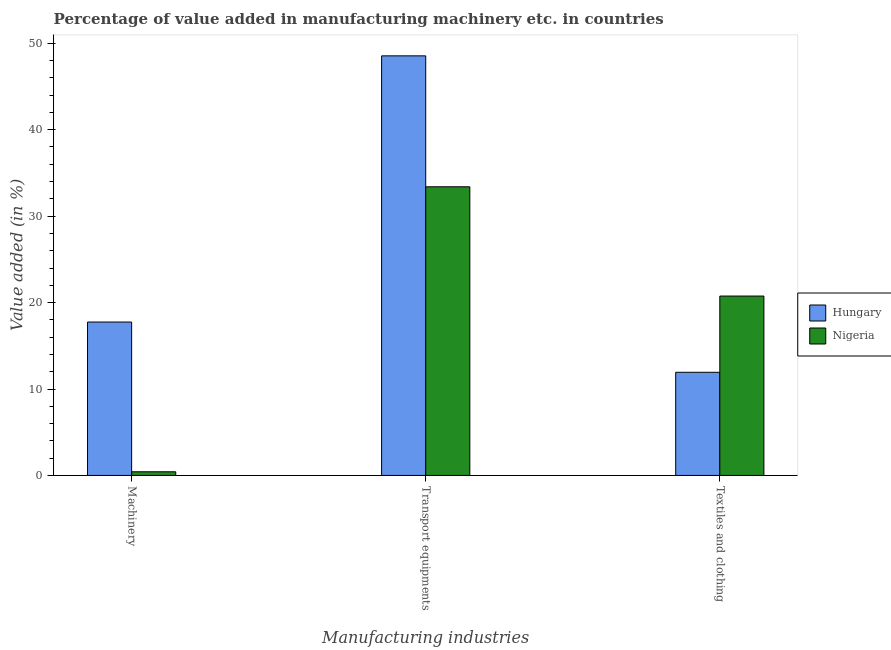How many groups of bars are there?
Provide a succinct answer. 3. How many bars are there on the 3rd tick from the left?
Ensure brevity in your answer.  2. How many bars are there on the 1st tick from the right?
Keep it short and to the point. 2. What is the label of the 2nd group of bars from the left?
Keep it short and to the point. Transport equipments. What is the value added in manufacturing transport equipments in Hungary?
Offer a terse response. 48.54. Across all countries, what is the maximum value added in manufacturing transport equipments?
Ensure brevity in your answer.  48.54. Across all countries, what is the minimum value added in manufacturing transport equipments?
Make the answer very short. 33.4. In which country was the value added in manufacturing transport equipments maximum?
Keep it short and to the point. Hungary. In which country was the value added in manufacturing textile and clothing minimum?
Your answer should be compact. Hungary. What is the total value added in manufacturing textile and clothing in the graph?
Provide a short and direct response. 32.69. What is the difference between the value added in manufacturing textile and clothing in Nigeria and that in Hungary?
Provide a short and direct response. 8.82. What is the difference between the value added in manufacturing textile and clothing in Nigeria and the value added in manufacturing machinery in Hungary?
Keep it short and to the point. 3.01. What is the average value added in manufacturing textile and clothing per country?
Provide a succinct answer. 16.34. What is the difference between the value added in manufacturing transport equipments and value added in manufacturing machinery in Hungary?
Your answer should be very brief. 30.8. What is the ratio of the value added in manufacturing machinery in Hungary to that in Nigeria?
Give a very brief answer. 41.93. Is the difference between the value added in manufacturing transport equipments in Hungary and Nigeria greater than the difference between the value added in manufacturing textile and clothing in Hungary and Nigeria?
Offer a terse response. Yes. What is the difference between the highest and the second highest value added in manufacturing textile and clothing?
Offer a very short reply. 8.82. What is the difference between the highest and the lowest value added in manufacturing machinery?
Your response must be concise. 17.33. In how many countries, is the value added in manufacturing textile and clothing greater than the average value added in manufacturing textile and clothing taken over all countries?
Provide a succinct answer. 1. What does the 1st bar from the left in Machinery represents?
Offer a terse response. Hungary. What does the 2nd bar from the right in Textiles and clothing represents?
Keep it short and to the point. Hungary. Are all the bars in the graph horizontal?
Offer a very short reply. No. Are the values on the major ticks of Y-axis written in scientific E-notation?
Offer a terse response. No. Where does the legend appear in the graph?
Provide a short and direct response. Center right. How are the legend labels stacked?
Offer a very short reply. Vertical. What is the title of the graph?
Make the answer very short. Percentage of value added in manufacturing machinery etc. in countries. What is the label or title of the X-axis?
Provide a short and direct response. Manufacturing industries. What is the label or title of the Y-axis?
Make the answer very short. Value added (in %). What is the Value added (in %) in Hungary in Machinery?
Provide a short and direct response. 17.75. What is the Value added (in %) of Nigeria in Machinery?
Your answer should be compact. 0.42. What is the Value added (in %) in Hungary in Transport equipments?
Provide a short and direct response. 48.54. What is the Value added (in %) of Nigeria in Transport equipments?
Ensure brevity in your answer.  33.4. What is the Value added (in %) of Hungary in Textiles and clothing?
Your answer should be very brief. 11.94. What is the Value added (in %) of Nigeria in Textiles and clothing?
Provide a short and direct response. 20.75. Across all Manufacturing industries, what is the maximum Value added (in %) of Hungary?
Keep it short and to the point. 48.54. Across all Manufacturing industries, what is the maximum Value added (in %) of Nigeria?
Offer a very short reply. 33.4. Across all Manufacturing industries, what is the minimum Value added (in %) in Hungary?
Your answer should be compact. 11.94. Across all Manufacturing industries, what is the minimum Value added (in %) of Nigeria?
Your answer should be very brief. 0.42. What is the total Value added (in %) of Hungary in the graph?
Offer a terse response. 78.23. What is the total Value added (in %) in Nigeria in the graph?
Offer a very short reply. 54.57. What is the difference between the Value added (in %) of Hungary in Machinery and that in Transport equipments?
Provide a short and direct response. -30.8. What is the difference between the Value added (in %) in Nigeria in Machinery and that in Transport equipments?
Offer a very short reply. -32.97. What is the difference between the Value added (in %) in Hungary in Machinery and that in Textiles and clothing?
Keep it short and to the point. 5.81. What is the difference between the Value added (in %) in Nigeria in Machinery and that in Textiles and clothing?
Give a very brief answer. -20.33. What is the difference between the Value added (in %) of Hungary in Transport equipments and that in Textiles and clothing?
Provide a succinct answer. 36.61. What is the difference between the Value added (in %) of Nigeria in Transport equipments and that in Textiles and clothing?
Keep it short and to the point. 12.64. What is the difference between the Value added (in %) of Hungary in Machinery and the Value added (in %) of Nigeria in Transport equipments?
Give a very brief answer. -15.65. What is the difference between the Value added (in %) in Hungary in Machinery and the Value added (in %) in Nigeria in Textiles and clothing?
Your response must be concise. -3.01. What is the difference between the Value added (in %) in Hungary in Transport equipments and the Value added (in %) in Nigeria in Textiles and clothing?
Your answer should be compact. 27.79. What is the average Value added (in %) of Hungary per Manufacturing industries?
Provide a short and direct response. 26.08. What is the average Value added (in %) of Nigeria per Manufacturing industries?
Keep it short and to the point. 18.19. What is the difference between the Value added (in %) in Hungary and Value added (in %) in Nigeria in Machinery?
Offer a very short reply. 17.33. What is the difference between the Value added (in %) of Hungary and Value added (in %) of Nigeria in Transport equipments?
Make the answer very short. 15.15. What is the difference between the Value added (in %) in Hungary and Value added (in %) in Nigeria in Textiles and clothing?
Keep it short and to the point. -8.82. What is the ratio of the Value added (in %) in Hungary in Machinery to that in Transport equipments?
Keep it short and to the point. 0.37. What is the ratio of the Value added (in %) in Nigeria in Machinery to that in Transport equipments?
Provide a succinct answer. 0.01. What is the ratio of the Value added (in %) of Hungary in Machinery to that in Textiles and clothing?
Provide a short and direct response. 1.49. What is the ratio of the Value added (in %) in Nigeria in Machinery to that in Textiles and clothing?
Offer a very short reply. 0.02. What is the ratio of the Value added (in %) of Hungary in Transport equipments to that in Textiles and clothing?
Make the answer very short. 4.07. What is the ratio of the Value added (in %) in Nigeria in Transport equipments to that in Textiles and clothing?
Provide a succinct answer. 1.61. What is the difference between the highest and the second highest Value added (in %) of Hungary?
Provide a short and direct response. 30.8. What is the difference between the highest and the second highest Value added (in %) of Nigeria?
Your answer should be very brief. 12.64. What is the difference between the highest and the lowest Value added (in %) of Hungary?
Make the answer very short. 36.61. What is the difference between the highest and the lowest Value added (in %) in Nigeria?
Ensure brevity in your answer.  32.97. 